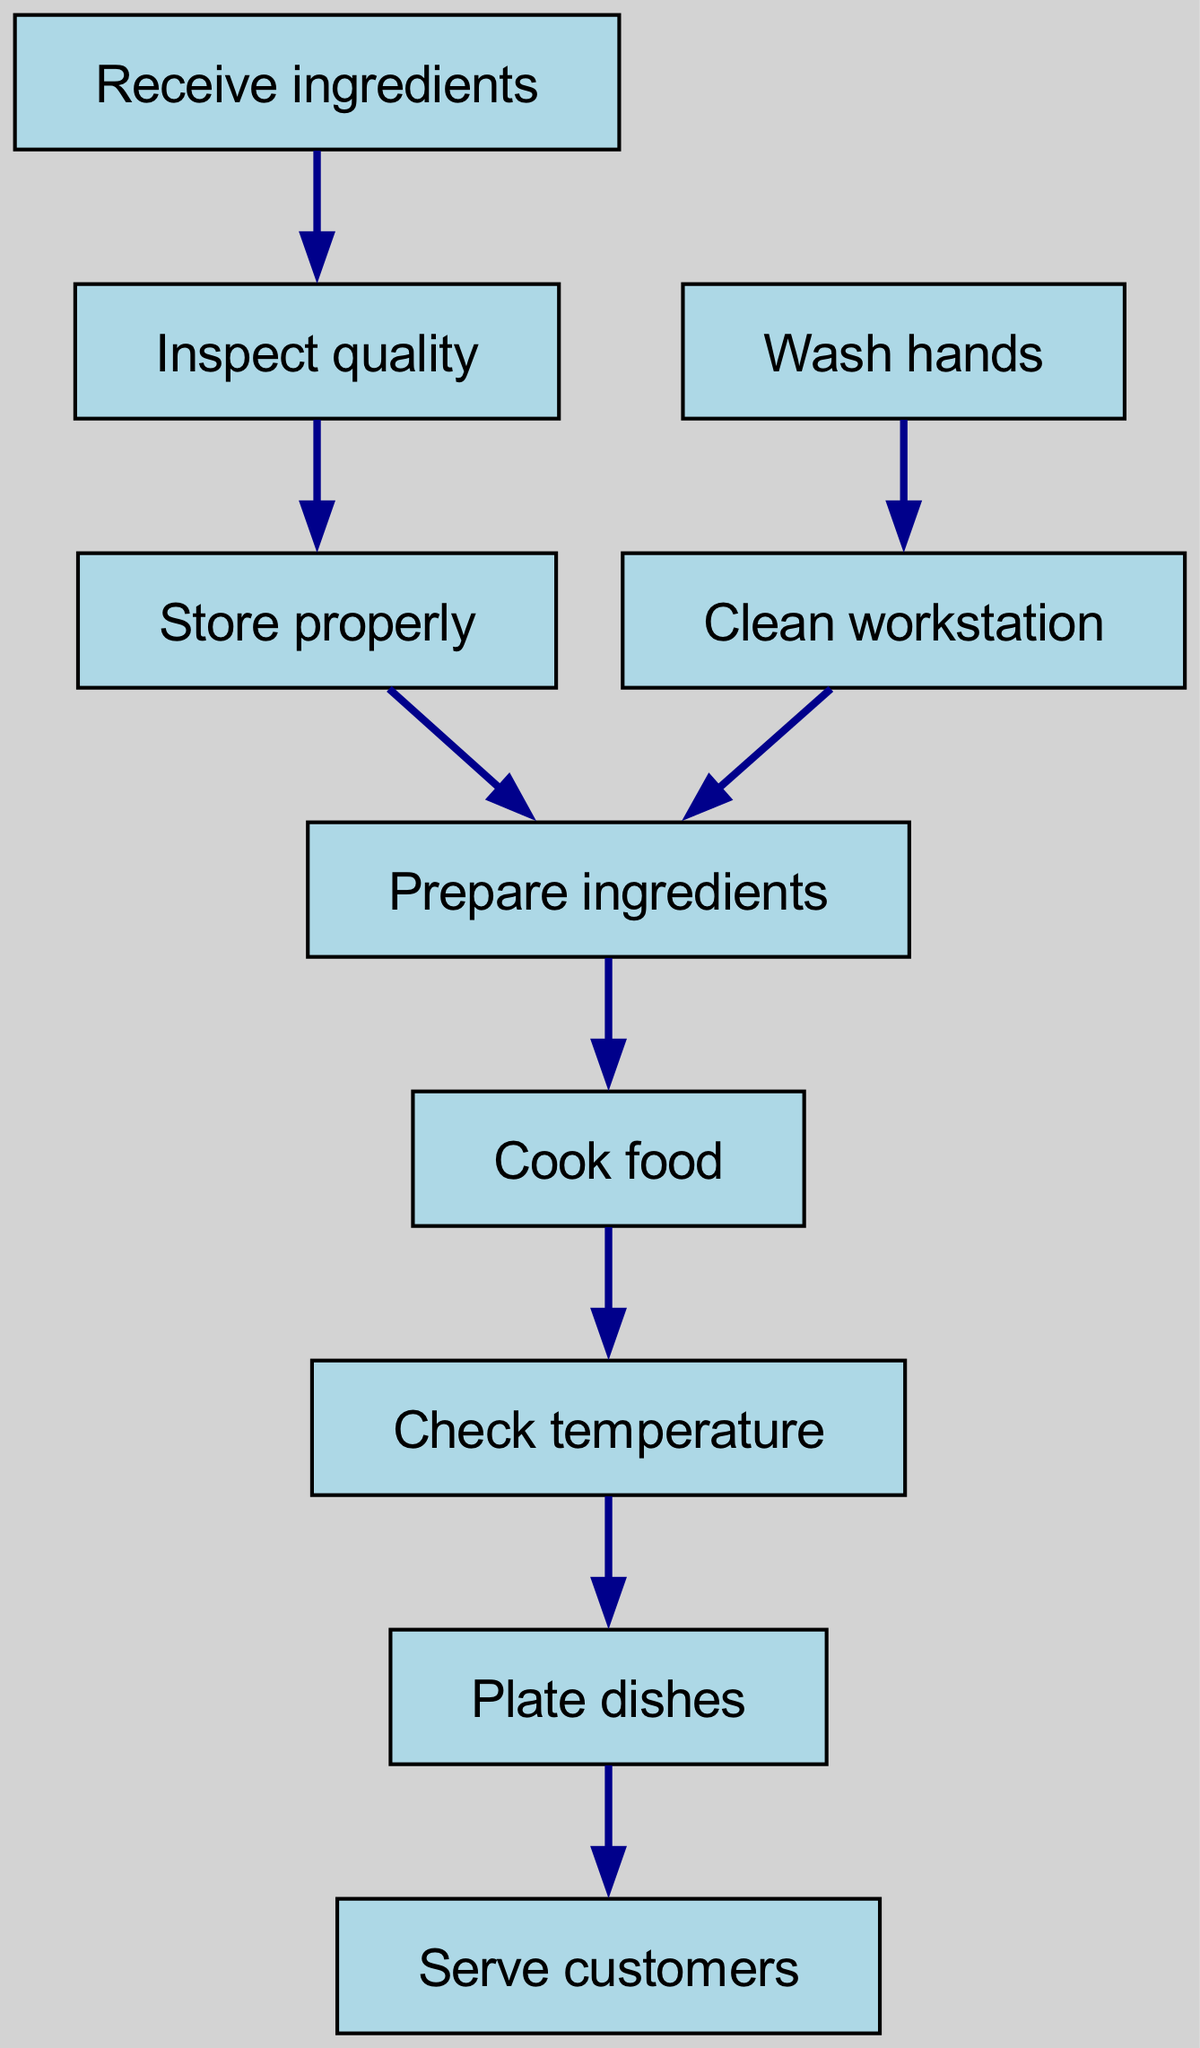What is the first step in the food safety compliance flowchart? The diagram starts with the node "Receive ingredients," which is the initial action in the process of food safety compliance.
Answer: Receive ingredients How many nodes are there in the diagram? By counting each unique step or action depicted in the flowchart, we find there are ten distinct nodes listed.
Answer: 10 What is the relationship between "Inspect quality" and "Store properly"? The diagram shows a directed edge from "Inspect quality" to "Store properly," indicating that after inspecting the quality of the ingredients, the next step is to store them properly.
Answer: Store properly What precedes "Cook food" in the flowchart? The diagram shows that the node "Prepare ingredients" is directly before "Cook food," signifying that preparation is necessary before cooking.
Answer: Prepare ingredients How many edges connect the nodes in the diagram? By analyzing the connections between the nodes, there are a total of nine edges that represent the relationships and flow between the different steps in the process.
Answer: 9 What must be done before preparing ingredients? According to the flowchart, both "Store properly" and "Clean workstation" lead to "Prepare ingredients." Therefore, either can be a prerequisite.
Answer: Store properly, Clean workstation What is the final action in the food safety compliance flowchart? The last node in the sequence is "Serve customers," indicating this is the final action to be completed after all preceding steps have been fulfilled.
Answer: Serve customers Which steps involve hand hygiene? The diagram specifies that "Wash hands" is an action that occurs before "Clean workstation," illustrating the importance of hand hygiene for food safety.
Answer: Wash hands What happens after cooking food? The flowchart demonstrates that the immediate next step after "Cook food" is to "Check temperature," ensuring that the food is cooked to the appropriate internal temperature.
Answer: Check temperature 